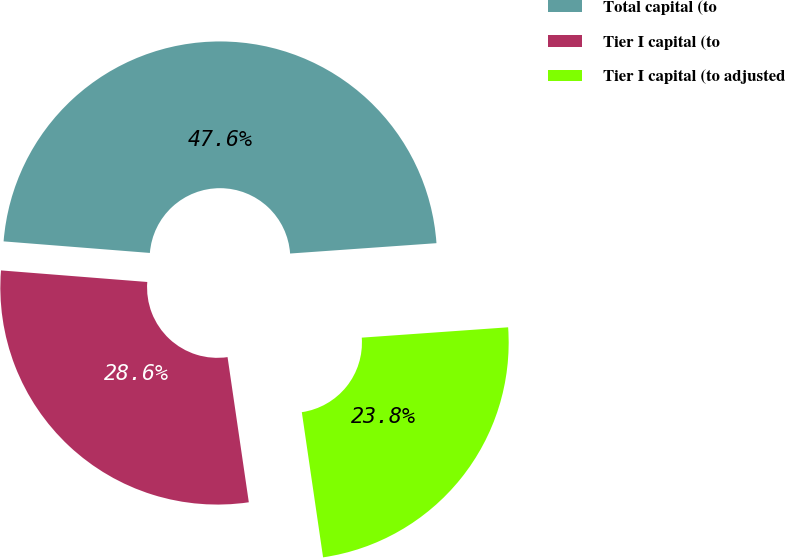Convert chart. <chart><loc_0><loc_0><loc_500><loc_500><pie_chart><fcel>Total capital (to<fcel>Tier I capital (to<fcel>Tier I capital (to adjusted<nl><fcel>47.62%<fcel>28.57%<fcel>23.81%<nl></chart> 